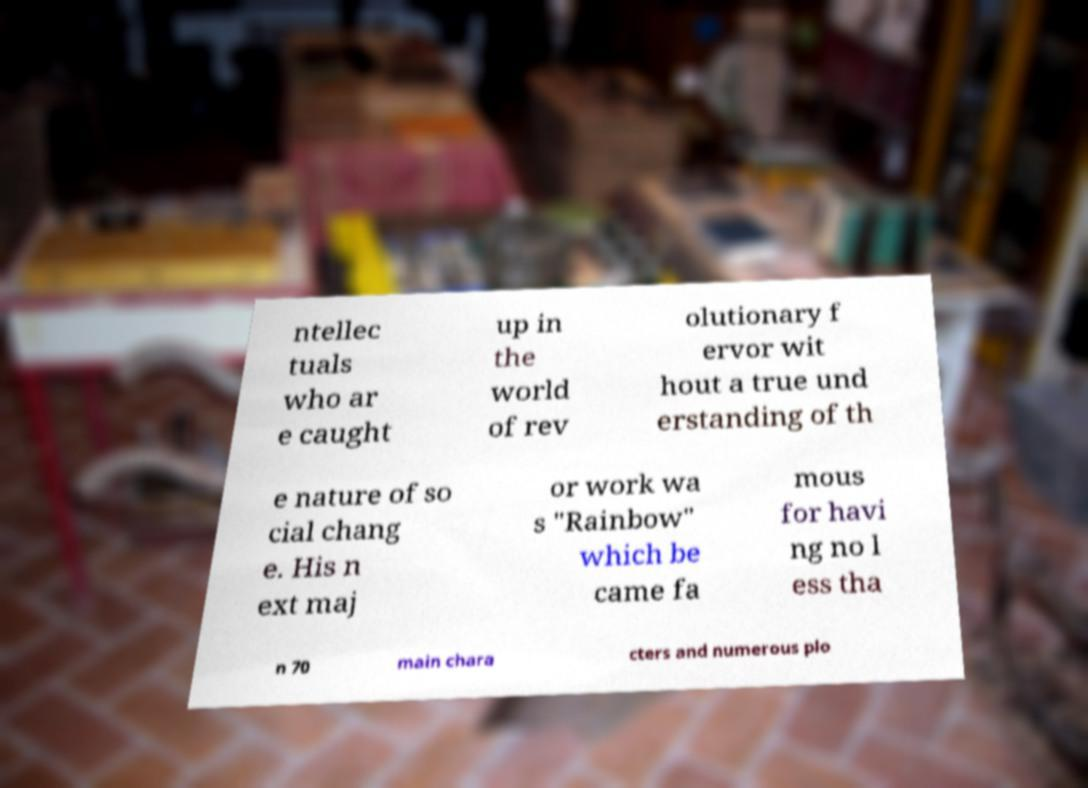Could you extract and type out the text from this image? ntellec tuals who ar e caught up in the world of rev olutionary f ervor wit hout a true und erstanding of th e nature of so cial chang e. His n ext maj or work wa s "Rainbow" which be came fa mous for havi ng no l ess tha n 70 main chara cters and numerous plo 